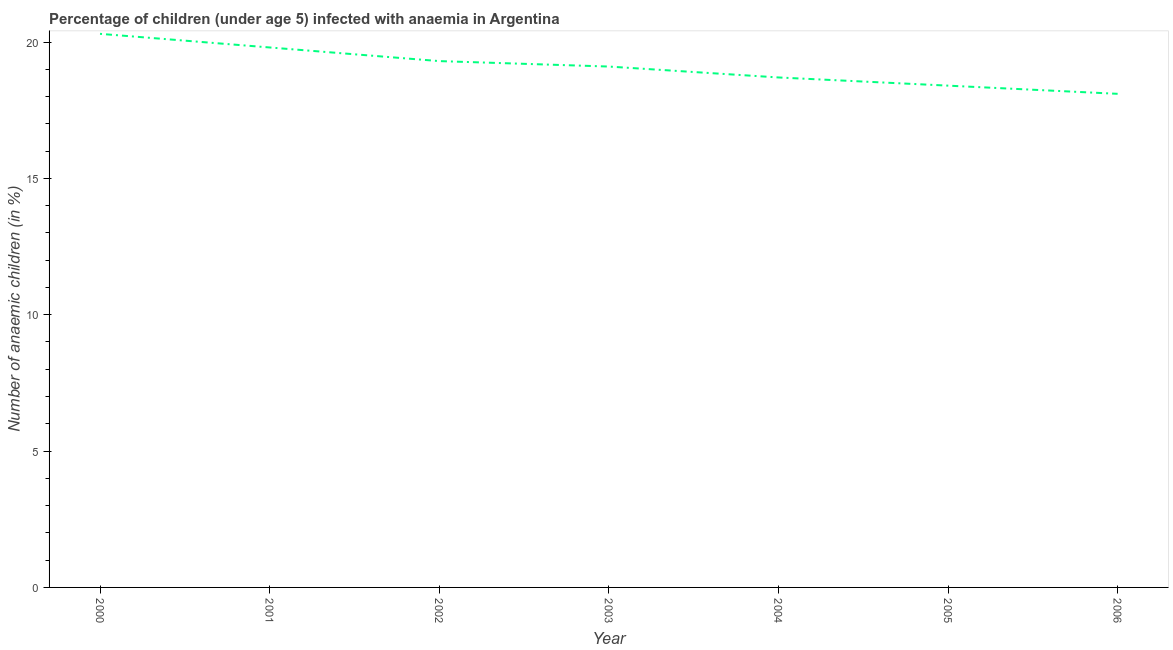Across all years, what is the maximum number of anaemic children?
Your answer should be compact. 20.3. In which year was the number of anaemic children minimum?
Offer a very short reply. 2006. What is the sum of the number of anaemic children?
Your response must be concise. 133.7. What is the difference between the number of anaemic children in 2002 and 2006?
Provide a short and direct response. 1.2. What is the average number of anaemic children per year?
Your answer should be very brief. 19.1. Do a majority of the years between 2001 and 2002 (inclusive) have number of anaemic children greater than 10 %?
Make the answer very short. Yes. What is the ratio of the number of anaemic children in 2000 to that in 2002?
Give a very brief answer. 1.05. Is the number of anaemic children in 2003 less than that in 2005?
Ensure brevity in your answer.  No. What is the difference between the highest and the second highest number of anaemic children?
Ensure brevity in your answer.  0.5. What is the difference between the highest and the lowest number of anaemic children?
Keep it short and to the point. 2.2. In how many years, is the number of anaemic children greater than the average number of anaemic children taken over all years?
Provide a short and direct response. 4. Does the number of anaemic children monotonically increase over the years?
Provide a succinct answer. No. How many years are there in the graph?
Offer a very short reply. 7. Are the values on the major ticks of Y-axis written in scientific E-notation?
Give a very brief answer. No. What is the title of the graph?
Provide a short and direct response. Percentage of children (under age 5) infected with anaemia in Argentina. What is the label or title of the X-axis?
Ensure brevity in your answer.  Year. What is the label or title of the Y-axis?
Offer a terse response. Number of anaemic children (in %). What is the Number of anaemic children (in %) of 2000?
Your response must be concise. 20.3. What is the Number of anaemic children (in %) in 2001?
Give a very brief answer. 19.8. What is the Number of anaemic children (in %) of 2002?
Offer a terse response. 19.3. What is the Number of anaemic children (in %) in 2004?
Offer a terse response. 18.7. What is the Number of anaemic children (in %) in 2005?
Provide a short and direct response. 18.4. What is the Number of anaemic children (in %) of 2006?
Your answer should be compact. 18.1. What is the difference between the Number of anaemic children (in %) in 2000 and 2001?
Provide a short and direct response. 0.5. What is the difference between the Number of anaemic children (in %) in 2000 and 2002?
Ensure brevity in your answer.  1. What is the difference between the Number of anaemic children (in %) in 2000 and 2004?
Your answer should be compact. 1.6. What is the difference between the Number of anaemic children (in %) in 2000 and 2006?
Keep it short and to the point. 2.2. What is the difference between the Number of anaemic children (in %) in 2001 and 2003?
Make the answer very short. 0.7. What is the difference between the Number of anaemic children (in %) in 2001 and 2004?
Offer a very short reply. 1.1. What is the difference between the Number of anaemic children (in %) in 2001 and 2005?
Offer a terse response. 1.4. What is the difference between the Number of anaemic children (in %) in 2002 and 2004?
Provide a succinct answer. 0.6. What is the difference between the Number of anaemic children (in %) in 2002 and 2006?
Make the answer very short. 1.2. What is the difference between the Number of anaemic children (in %) in 2003 and 2006?
Your response must be concise. 1. What is the difference between the Number of anaemic children (in %) in 2004 and 2006?
Offer a terse response. 0.6. What is the difference between the Number of anaemic children (in %) in 2005 and 2006?
Your answer should be compact. 0.3. What is the ratio of the Number of anaemic children (in %) in 2000 to that in 2001?
Offer a terse response. 1.02. What is the ratio of the Number of anaemic children (in %) in 2000 to that in 2002?
Offer a very short reply. 1.05. What is the ratio of the Number of anaemic children (in %) in 2000 to that in 2003?
Ensure brevity in your answer.  1.06. What is the ratio of the Number of anaemic children (in %) in 2000 to that in 2004?
Make the answer very short. 1.09. What is the ratio of the Number of anaemic children (in %) in 2000 to that in 2005?
Keep it short and to the point. 1.1. What is the ratio of the Number of anaemic children (in %) in 2000 to that in 2006?
Ensure brevity in your answer.  1.12. What is the ratio of the Number of anaemic children (in %) in 2001 to that in 2004?
Offer a very short reply. 1.06. What is the ratio of the Number of anaemic children (in %) in 2001 to that in 2005?
Provide a succinct answer. 1.08. What is the ratio of the Number of anaemic children (in %) in 2001 to that in 2006?
Keep it short and to the point. 1.09. What is the ratio of the Number of anaemic children (in %) in 2002 to that in 2003?
Provide a succinct answer. 1.01. What is the ratio of the Number of anaemic children (in %) in 2002 to that in 2004?
Your answer should be compact. 1.03. What is the ratio of the Number of anaemic children (in %) in 2002 to that in 2005?
Your answer should be compact. 1.05. What is the ratio of the Number of anaemic children (in %) in 2002 to that in 2006?
Your response must be concise. 1.07. What is the ratio of the Number of anaemic children (in %) in 2003 to that in 2005?
Make the answer very short. 1.04. What is the ratio of the Number of anaemic children (in %) in 2003 to that in 2006?
Give a very brief answer. 1.05. What is the ratio of the Number of anaemic children (in %) in 2004 to that in 2006?
Your response must be concise. 1.03. 